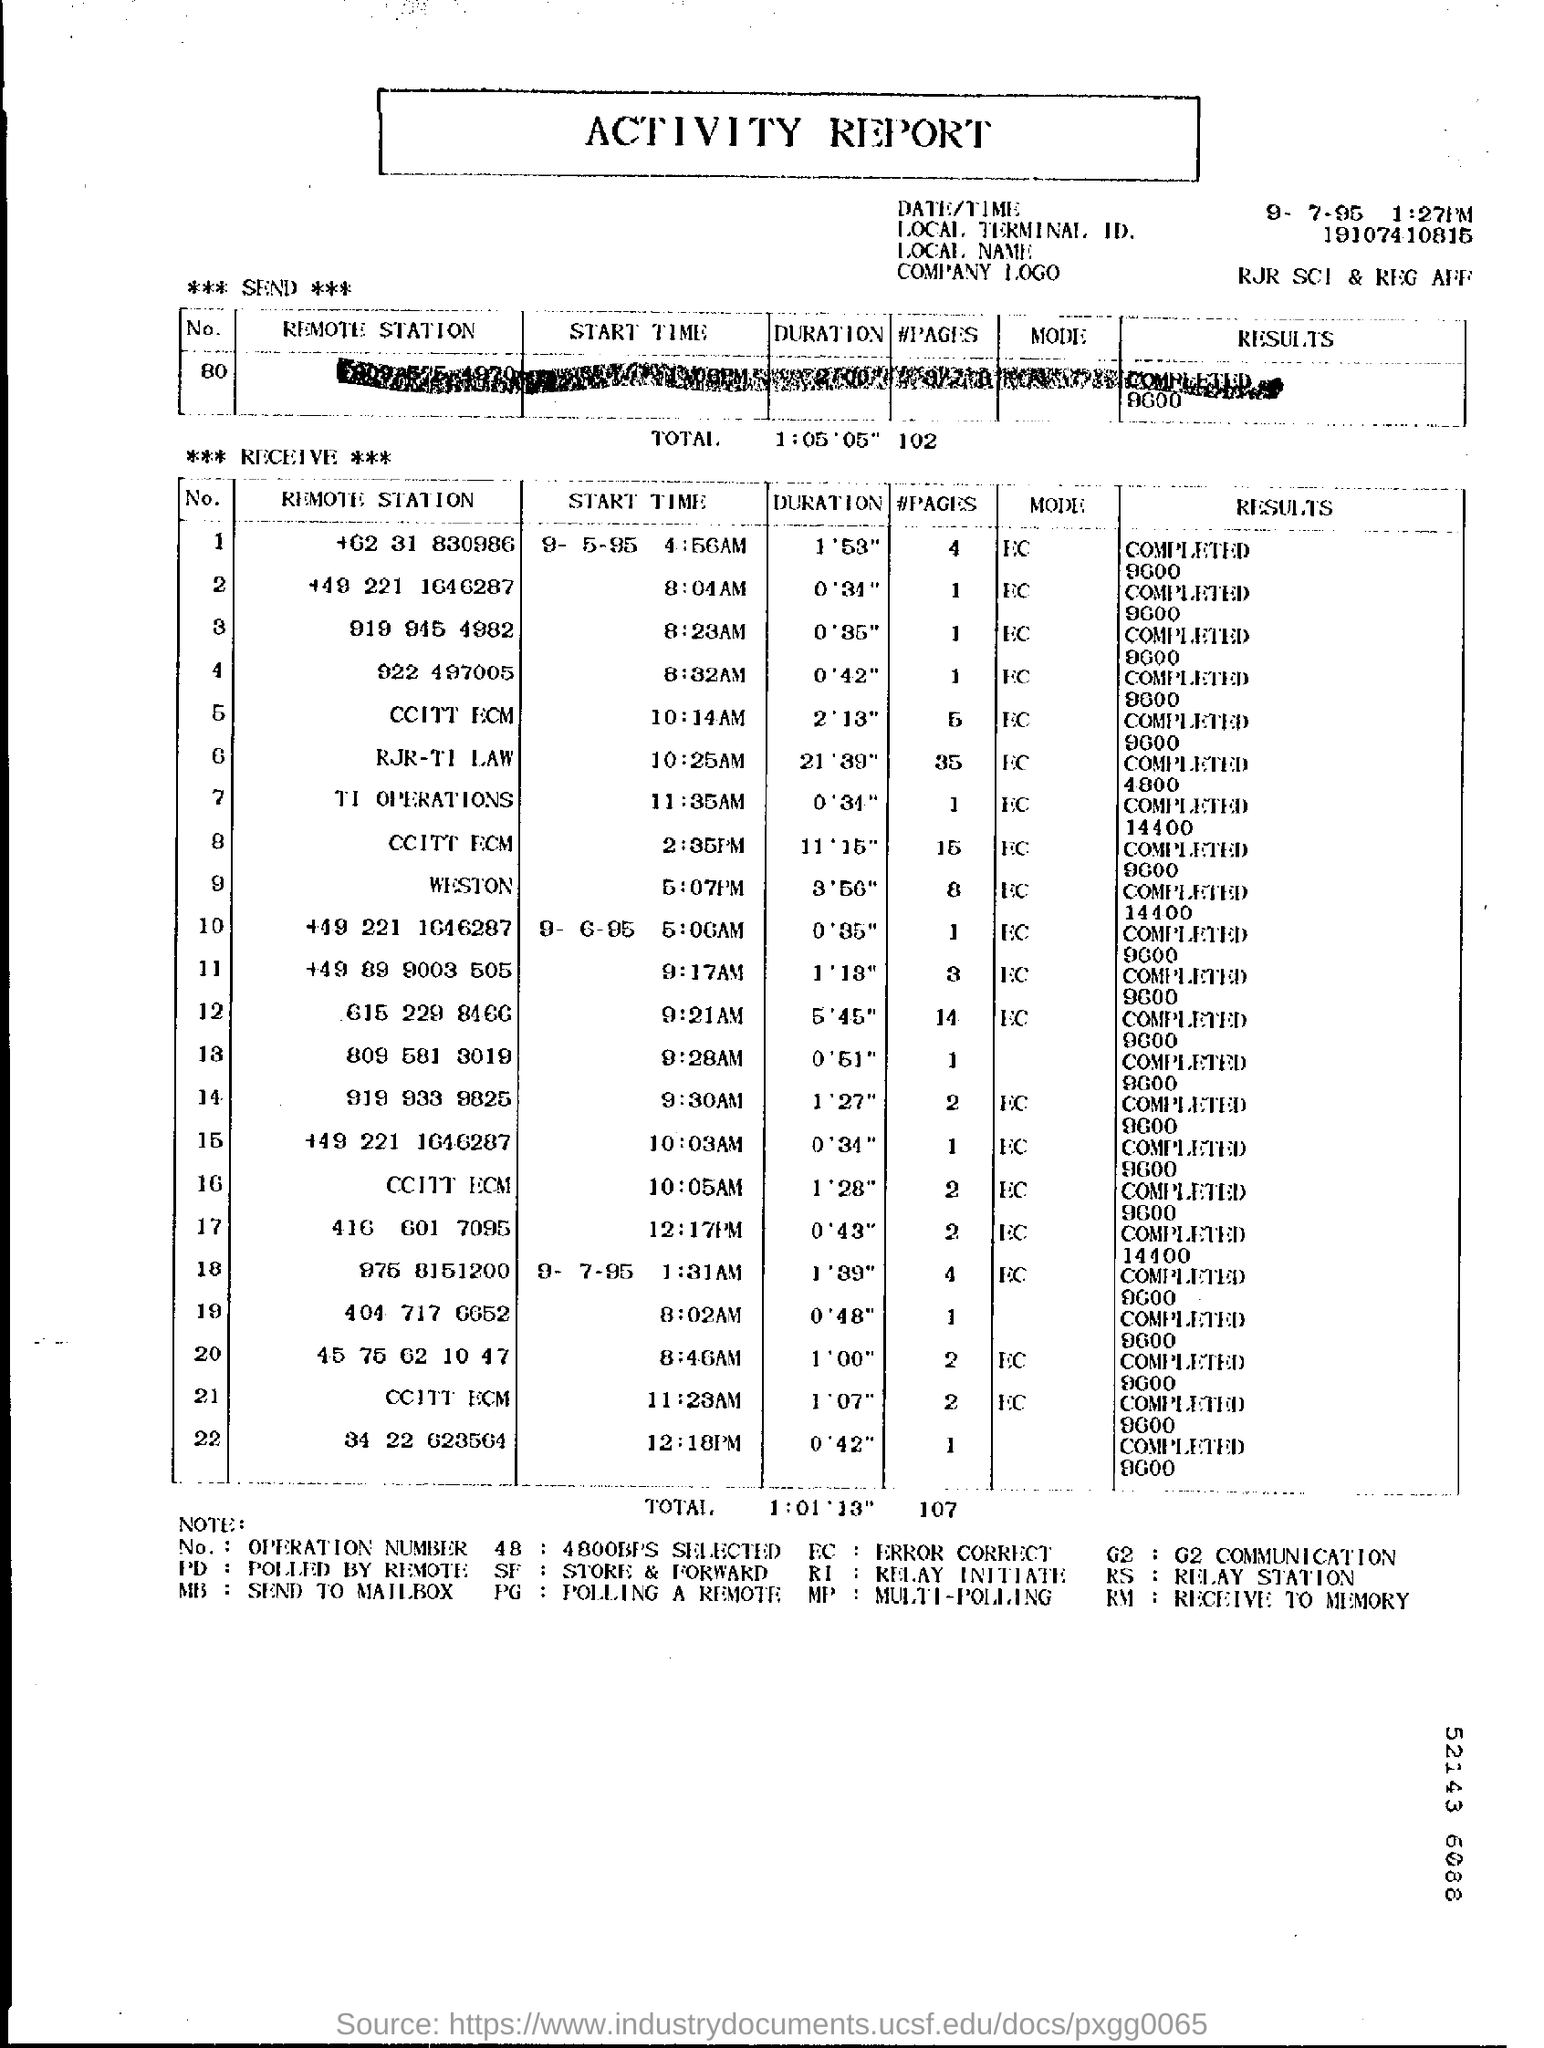What kind of REPORT is this?
Make the answer very short. ACTIVITY REPORT. What is the date given at the right top corner of the report?
Ensure brevity in your answer.  9- 7- 95. What is the time mentioned at the right top corner of the report?
Keep it short and to the point. 1 :27PM. What is the LOCAL TERMINAL ID.?
Provide a short and direct response. 19107410815. What is the first remote station number given in the table "receive"?
Offer a very short reply. +62 31 830986. What is the MODE corresponding to NO. 1?
Make the answer very short. EC. What is the RESULTS corresponding to NO. 1?
Ensure brevity in your answer.  Completed 9600. What does "MB" code stand for?
Your answer should be very brief. Send to mailbox. What is the expansion of PG?
Your answer should be compact. Polling a remote. What is the expansion of RM?
Your answer should be very brief. Receive to memory. What is the expansion of RS?
Provide a short and direct response. RELAY STATION. 